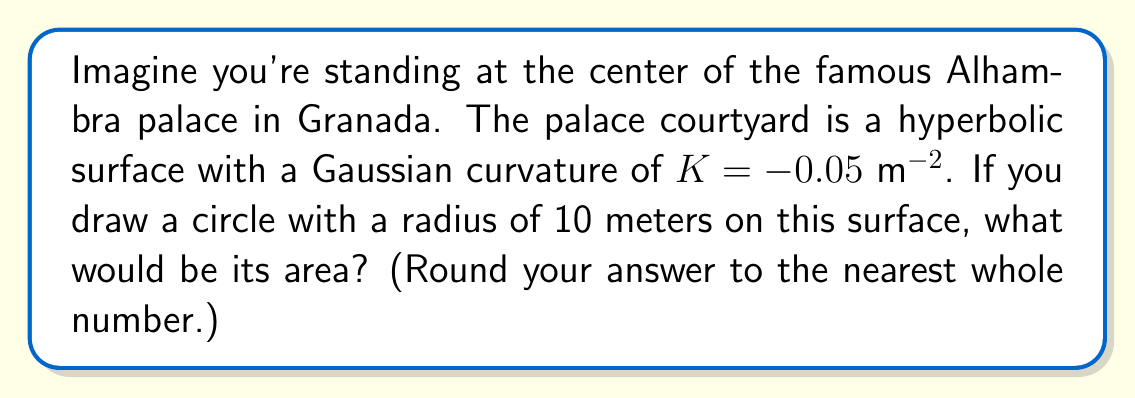Teach me how to tackle this problem. To solve this problem, we need to use the formula for the area of a circle on a hyperbolic surface. The steps are as follows:

1) The formula for the area of a circle on a hyperbolic surface with constant negative curvature $K$ is:

   $$A = \frac{4\pi}{|K|} \sinh^2\left(\frac{\sqrt{|K|}}{2}r\right)$$

   Where $r$ is the radius of the circle.

2) We're given:
   $K = -0.05$ m⁻²
   $r = 10$ m

3) Let's substitute these values into our formula:

   $$A = \frac{4\pi}{|-0.05|} \sinh^2\left(\frac{\sqrt{|-0.05|}}{2}10\right)$$

4) Simplify:
   $$A = \frac{4\pi}{0.05} \sinh^2(0.5\sqrt{0.05} \cdot 10)$$
   $$A = 80\pi \sinh^2(\sqrt{1.25})$$

5) Calculate:
   $$A \approx 80\pi \sinh^2(1.118)$$
   $$A \approx 80\pi \cdot 1.718$$
   $$A \approx 431.85 \text{ m}^2$$

6) Rounding to the nearest whole number:
   $$A \approx 432 \text{ m}^2$$
Answer: 432 m² 